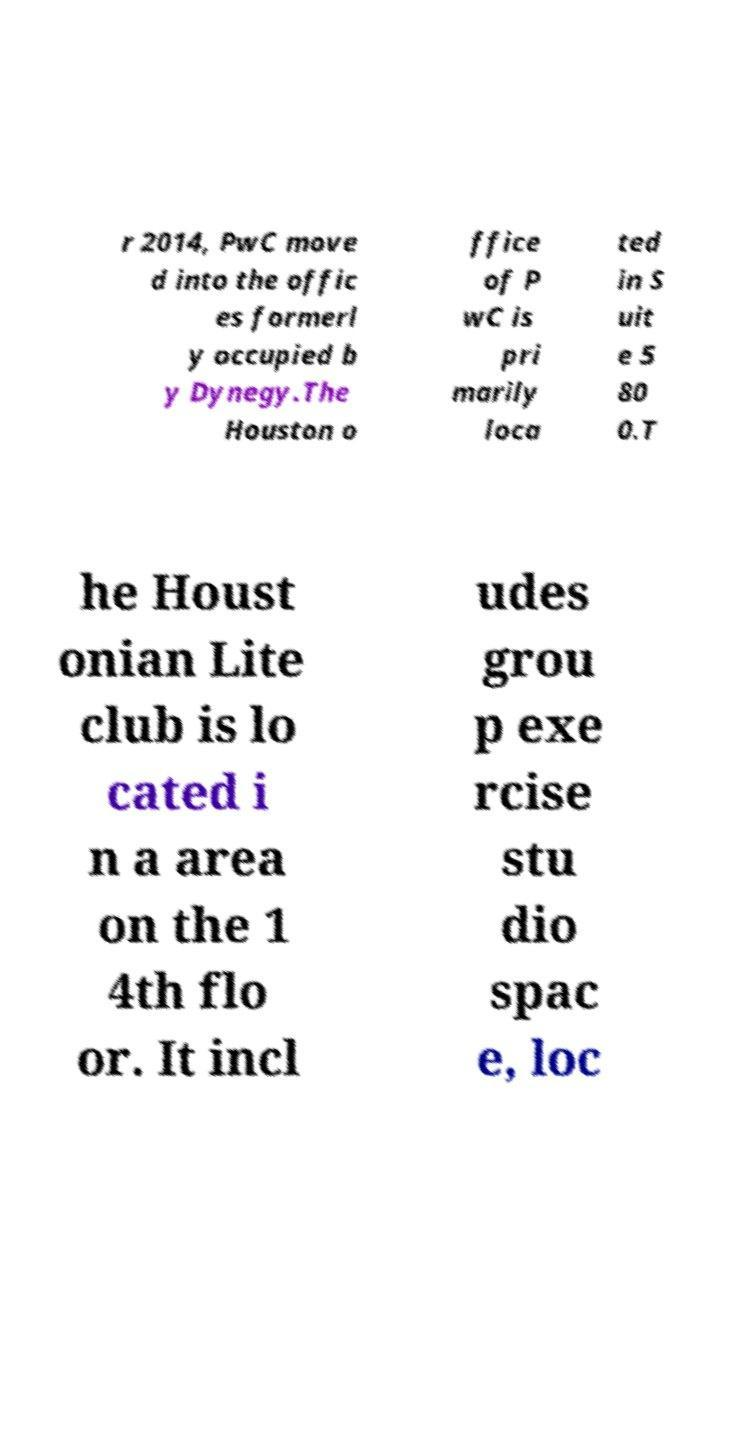What messages or text are displayed in this image? I need them in a readable, typed format. r 2014, PwC move d into the offic es formerl y occupied b y Dynegy.The Houston o ffice of P wC is pri marily loca ted in S uit e 5 80 0.T he Houst onian Lite club is lo cated i n a area on the 1 4th flo or. It incl udes grou p exe rcise stu dio spac e, loc 